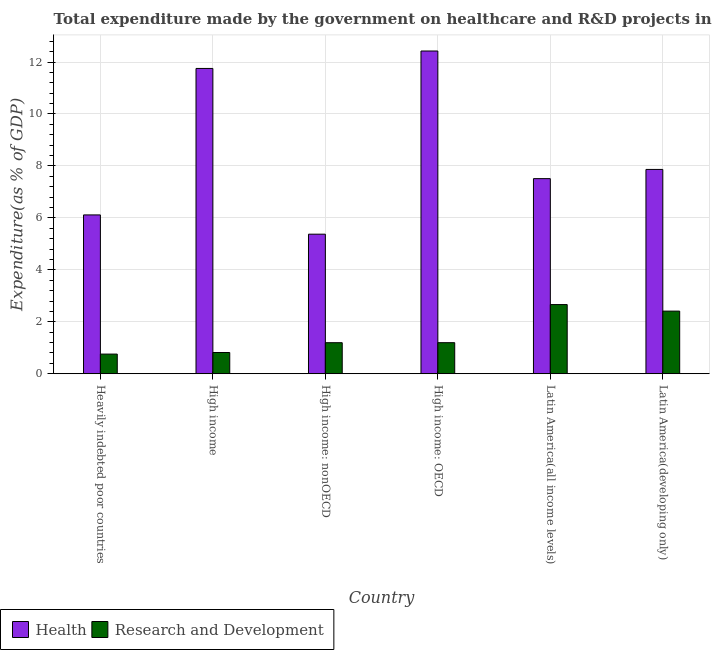How many groups of bars are there?
Offer a terse response. 6. Are the number of bars on each tick of the X-axis equal?
Your response must be concise. Yes. What is the label of the 6th group of bars from the left?
Your response must be concise. Latin America(developing only). What is the expenditure in healthcare in High income?
Your answer should be compact. 11.75. Across all countries, what is the maximum expenditure in healthcare?
Provide a succinct answer. 12.42. Across all countries, what is the minimum expenditure in healthcare?
Offer a very short reply. 5.37. In which country was the expenditure in r&d maximum?
Provide a succinct answer. Latin America(all income levels). In which country was the expenditure in healthcare minimum?
Your answer should be very brief. High income: nonOECD. What is the total expenditure in r&d in the graph?
Offer a very short reply. 9.04. What is the difference between the expenditure in healthcare in High income: OECD and that in Latin America(all income levels)?
Provide a short and direct response. 4.91. What is the difference between the expenditure in healthcare in High income: OECD and the expenditure in r&d in Latin America(developing only)?
Your answer should be compact. 10.01. What is the average expenditure in r&d per country?
Offer a very short reply. 1.51. What is the difference between the expenditure in r&d and expenditure in healthcare in High income: nonOECD?
Keep it short and to the point. -4.18. In how many countries, is the expenditure in r&d greater than 3.2 %?
Make the answer very short. 0. What is the ratio of the expenditure in healthcare in High income to that in Latin America(developing only)?
Provide a short and direct response. 1.49. Is the difference between the expenditure in healthcare in High income: OECD and Latin America(all income levels) greater than the difference between the expenditure in r&d in High income: OECD and Latin America(all income levels)?
Your answer should be very brief. Yes. What is the difference between the highest and the second highest expenditure in r&d?
Make the answer very short. 0.25. What is the difference between the highest and the lowest expenditure in healthcare?
Provide a succinct answer. 7.05. In how many countries, is the expenditure in r&d greater than the average expenditure in r&d taken over all countries?
Your answer should be very brief. 2. Is the sum of the expenditure in healthcare in Heavily indebted poor countries and High income: OECD greater than the maximum expenditure in r&d across all countries?
Your response must be concise. Yes. What does the 1st bar from the left in Latin America(developing only) represents?
Your answer should be very brief. Health. What does the 1st bar from the right in High income: OECD represents?
Provide a succinct answer. Research and Development. How many bars are there?
Your response must be concise. 12. Are all the bars in the graph horizontal?
Your answer should be compact. No. What is the difference between two consecutive major ticks on the Y-axis?
Provide a short and direct response. 2. Are the values on the major ticks of Y-axis written in scientific E-notation?
Offer a very short reply. No. Where does the legend appear in the graph?
Your response must be concise. Bottom left. What is the title of the graph?
Your response must be concise. Total expenditure made by the government on healthcare and R&D projects in 2011. What is the label or title of the Y-axis?
Your answer should be compact. Expenditure(as % of GDP). What is the Expenditure(as % of GDP) in Health in Heavily indebted poor countries?
Provide a short and direct response. 6.11. What is the Expenditure(as % of GDP) of Research and Development in Heavily indebted poor countries?
Offer a very short reply. 0.76. What is the Expenditure(as % of GDP) in Health in High income?
Ensure brevity in your answer.  11.75. What is the Expenditure(as % of GDP) in Research and Development in High income?
Offer a terse response. 0.82. What is the Expenditure(as % of GDP) in Health in High income: nonOECD?
Provide a short and direct response. 5.37. What is the Expenditure(as % of GDP) of Research and Development in High income: nonOECD?
Provide a succinct answer. 1.2. What is the Expenditure(as % of GDP) in Health in High income: OECD?
Your answer should be very brief. 12.42. What is the Expenditure(as % of GDP) in Research and Development in High income: OECD?
Your answer should be very brief. 1.2. What is the Expenditure(as % of GDP) of Health in Latin America(all income levels)?
Provide a succinct answer. 7.51. What is the Expenditure(as % of GDP) of Research and Development in Latin America(all income levels)?
Offer a very short reply. 2.66. What is the Expenditure(as % of GDP) in Health in Latin America(developing only)?
Your answer should be compact. 7.87. What is the Expenditure(as % of GDP) of Research and Development in Latin America(developing only)?
Ensure brevity in your answer.  2.41. Across all countries, what is the maximum Expenditure(as % of GDP) in Health?
Your response must be concise. 12.42. Across all countries, what is the maximum Expenditure(as % of GDP) of Research and Development?
Make the answer very short. 2.66. Across all countries, what is the minimum Expenditure(as % of GDP) in Health?
Offer a terse response. 5.37. Across all countries, what is the minimum Expenditure(as % of GDP) in Research and Development?
Offer a terse response. 0.76. What is the total Expenditure(as % of GDP) in Health in the graph?
Make the answer very short. 51.04. What is the total Expenditure(as % of GDP) in Research and Development in the graph?
Your answer should be very brief. 9.04. What is the difference between the Expenditure(as % of GDP) of Health in Heavily indebted poor countries and that in High income?
Provide a short and direct response. -5.64. What is the difference between the Expenditure(as % of GDP) of Research and Development in Heavily indebted poor countries and that in High income?
Provide a succinct answer. -0.06. What is the difference between the Expenditure(as % of GDP) of Health in Heavily indebted poor countries and that in High income: nonOECD?
Your answer should be compact. 0.74. What is the difference between the Expenditure(as % of GDP) of Research and Development in Heavily indebted poor countries and that in High income: nonOECD?
Make the answer very short. -0.44. What is the difference between the Expenditure(as % of GDP) in Health in Heavily indebted poor countries and that in High income: OECD?
Give a very brief answer. -6.31. What is the difference between the Expenditure(as % of GDP) in Research and Development in Heavily indebted poor countries and that in High income: OECD?
Provide a succinct answer. -0.44. What is the difference between the Expenditure(as % of GDP) of Health in Heavily indebted poor countries and that in Latin America(all income levels)?
Your answer should be compact. -1.4. What is the difference between the Expenditure(as % of GDP) in Research and Development in Heavily indebted poor countries and that in Latin America(all income levels)?
Offer a terse response. -1.91. What is the difference between the Expenditure(as % of GDP) in Health in Heavily indebted poor countries and that in Latin America(developing only)?
Make the answer very short. -1.75. What is the difference between the Expenditure(as % of GDP) of Research and Development in Heavily indebted poor countries and that in Latin America(developing only)?
Give a very brief answer. -1.65. What is the difference between the Expenditure(as % of GDP) in Health in High income and that in High income: nonOECD?
Give a very brief answer. 6.38. What is the difference between the Expenditure(as % of GDP) of Research and Development in High income and that in High income: nonOECD?
Offer a terse response. -0.38. What is the difference between the Expenditure(as % of GDP) in Health in High income and that in High income: OECD?
Offer a terse response. -0.67. What is the difference between the Expenditure(as % of GDP) of Research and Development in High income and that in High income: OECD?
Offer a very short reply. -0.38. What is the difference between the Expenditure(as % of GDP) in Health in High income and that in Latin America(all income levels)?
Offer a terse response. 4.24. What is the difference between the Expenditure(as % of GDP) of Research and Development in High income and that in Latin America(all income levels)?
Ensure brevity in your answer.  -1.85. What is the difference between the Expenditure(as % of GDP) of Health in High income and that in Latin America(developing only)?
Your answer should be very brief. 3.89. What is the difference between the Expenditure(as % of GDP) of Research and Development in High income and that in Latin America(developing only)?
Keep it short and to the point. -1.59. What is the difference between the Expenditure(as % of GDP) in Health in High income: nonOECD and that in High income: OECD?
Give a very brief answer. -7.05. What is the difference between the Expenditure(as % of GDP) in Research and Development in High income: nonOECD and that in High income: OECD?
Provide a succinct answer. -0. What is the difference between the Expenditure(as % of GDP) of Health in High income: nonOECD and that in Latin America(all income levels)?
Provide a short and direct response. -2.14. What is the difference between the Expenditure(as % of GDP) of Research and Development in High income: nonOECD and that in Latin America(all income levels)?
Provide a short and direct response. -1.47. What is the difference between the Expenditure(as % of GDP) of Health in High income: nonOECD and that in Latin America(developing only)?
Make the answer very short. -2.49. What is the difference between the Expenditure(as % of GDP) in Research and Development in High income: nonOECD and that in Latin America(developing only)?
Give a very brief answer. -1.22. What is the difference between the Expenditure(as % of GDP) in Health in High income: OECD and that in Latin America(all income levels)?
Ensure brevity in your answer.  4.91. What is the difference between the Expenditure(as % of GDP) in Research and Development in High income: OECD and that in Latin America(all income levels)?
Provide a short and direct response. -1.47. What is the difference between the Expenditure(as % of GDP) of Health in High income: OECD and that in Latin America(developing only)?
Offer a terse response. 4.56. What is the difference between the Expenditure(as % of GDP) in Research and Development in High income: OECD and that in Latin America(developing only)?
Provide a short and direct response. -1.21. What is the difference between the Expenditure(as % of GDP) in Health in Latin America(all income levels) and that in Latin America(developing only)?
Offer a very short reply. -0.35. What is the difference between the Expenditure(as % of GDP) of Research and Development in Latin America(all income levels) and that in Latin America(developing only)?
Your response must be concise. 0.25. What is the difference between the Expenditure(as % of GDP) of Health in Heavily indebted poor countries and the Expenditure(as % of GDP) of Research and Development in High income?
Your answer should be compact. 5.3. What is the difference between the Expenditure(as % of GDP) of Health in Heavily indebted poor countries and the Expenditure(as % of GDP) of Research and Development in High income: nonOECD?
Provide a short and direct response. 4.92. What is the difference between the Expenditure(as % of GDP) of Health in Heavily indebted poor countries and the Expenditure(as % of GDP) of Research and Development in High income: OECD?
Give a very brief answer. 4.92. What is the difference between the Expenditure(as % of GDP) in Health in Heavily indebted poor countries and the Expenditure(as % of GDP) in Research and Development in Latin America(all income levels)?
Make the answer very short. 3.45. What is the difference between the Expenditure(as % of GDP) of Health in Heavily indebted poor countries and the Expenditure(as % of GDP) of Research and Development in Latin America(developing only)?
Offer a very short reply. 3.7. What is the difference between the Expenditure(as % of GDP) of Health in High income and the Expenditure(as % of GDP) of Research and Development in High income: nonOECD?
Your response must be concise. 10.56. What is the difference between the Expenditure(as % of GDP) in Health in High income and the Expenditure(as % of GDP) in Research and Development in High income: OECD?
Keep it short and to the point. 10.56. What is the difference between the Expenditure(as % of GDP) in Health in High income and the Expenditure(as % of GDP) in Research and Development in Latin America(all income levels)?
Your answer should be compact. 9.09. What is the difference between the Expenditure(as % of GDP) in Health in High income and the Expenditure(as % of GDP) in Research and Development in Latin America(developing only)?
Offer a terse response. 9.34. What is the difference between the Expenditure(as % of GDP) in Health in High income: nonOECD and the Expenditure(as % of GDP) in Research and Development in High income: OECD?
Your response must be concise. 4.18. What is the difference between the Expenditure(as % of GDP) in Health in High income: nonOECD and the Expenditure(as % of GDP) in Research and Development in Latin America(all income levels)?
Give a very brief answer. 2.71. What is the difference between the Expenditure(as % of GDP) of Health in High income: nonOECD and the Expenditure(as % of GDP) of Research and Development in Latin America(developing only)?
Keep it short and to the point. 2.96. What is the difference between the Expenditure(as % of GDP) in Health in High income: OECD and the Expenditure(as % of GDP) in Research and Development in Latin America(all income levels)?
Offer a very short reply. 9.76. What is the difference between the Expenditure(as % of GDP) in Health in High income: OECD and the Expenditure(as % of GDP) in Research and Development in Latin America(developing only)?
Provide a short and direct response. 10.01. What is the difference between the Expenditure(as % of GDP) in Health in Latin America(all income levels) and the Expenditure(as % of GDP) in Research and Development in Latin America(developing only)?
Offer a terse response. 5.1. What is the average Expenditure(as % of GDP) of Health per country?
Provide a short and direct response. 8.51. What is the average Expenditure(as % of GDP) in Research and Development per country?
Provide a short and direct response. 1.51. What is the difference between the Expenditure(as % of GDP) of Health and Expenditure(as % of GDP) of Research and Development in Heavily indebted poor countries?
Ensure brevity in your answer.  5.36. What is the difference between the Expenditure(as % of GDP) of Health and Expenditure(as % of GDP) of Research and Development in High income?
Keep it short and to the point. 10.94. What is the difference between the Expenditure(as % of GDP) in Health and Expenditure(as % of GDP) in Research and Development in High income: nonOECD?
Your response must be concise. 4.18. What is the difference between the Expenditure(as % of GDP) of Health and Expenditure(as % of GDP) of Research and Development in High income: OECD?
Your answer should be very brief. 11.23. What is the difference between the Expenditure(as % of GDP) in Health and Expenditure(as % of GDP) in Research and Development in Latin America(all income levels)?
Make the answer very short. 4.85. What is the difference between the Expenditure(as % of GDP) in Health and Expenditure(as % of GDP) in Research and Development in Latin America(developing only)?
Your response must be concise. 5.45. What is the ratio of the Expenditure(as % of GDP) in Health in Heavily indebted poor countries to that in High income?
Provide a short and direct response. 0.52. What is the ratio of the Expenditure(as % of GDP) of Research and Development in Heavily indebted poor countries to that in High income?
Give a very brief answer. 0.93. What is the ratio of the Expenditure(as % of GDP) of Health in Heavily indebted poor countries to that in High income: nonOECD?
Offer a terse response. 1.14. What is the ratio of the Expenditure(as % of GDP) in Research and Development in Heavily indebted poor countries to that in High income: nonOECD?
Your answer should be compact. 0.63. What is the ratio of the Expenditure(as % of GDP) of Health in Heavily indebted poor countries to that in High income: OECD?
Ensure brevity in your answer.  0.49. What is the ratio of the Expenditure(as % of GDP) of Research and Development in Heavily indebted poor countries to that in High income: OECD?
Your response must be concise. 0.63. What is the ratio of the Expenditure(as % of GDP) in Health in Heavily indebted poor countries to that in Latin America(all income levels)?
Your answer should be very brief. 0.81. What is the ratio of the Expenditure(as % of GDP) of Research and Development in Heavily indebted poor countries to that in Latin America(all income levels)?
Provide a short and direct response. 0.28. What is the ratio of the Expenditure(as % of GDP) in Health in Heavily indebted poor countries to that in Latin America(developing only)?
Your answer should be compact. 0.78. What is the ratio of the Expenditure(as % of GDP) of Research and Development in Heavily indebted poor countries to that in Latin America(developing only)?
Provide a short and direct response. 0.31. What is the ratio of the Expenditure(as % of GDP) of Health in High income to that in High income: nonOECD?
Your answer should be very brief. 2.19. What is the ratio of the Expenditure(as % of GDP) of Research and Development in High income to that in High income: nonOECD?
Your answer should be very brief. 0.68. What is the ratio of the Expenditure(as % of GDP) in Health in High income to that in High income: OECD?
Your answer should be very brief. 0.95. What is the ratio of the Expenditure(as % of GDP) of Research and Development in High income to that in High income: OECD?
Keep it short and to the point. 0.68. What is the ratio of the Expenditure(as % of GDP) of Health in High income to that in Latin America(all income levels)?
Your answer should be very brief. 1.56. What is the ratio of the Expenditure(as % of GDP) of Research and Development in High income to that in Latin America(all income levels)?
Offer a terse response. 0.31. What is the ratio of the Expenditure(as % of GDP) in Health in High income to that in Latin America(developing only)?
Provide a short and direct response. 1.49. What is the ratio of the Expenditure(as % of GDP) of Research and Development in High income to that in Latin America(developing only)?
Make the answer very short. 0.34. What is the ratio of the Expenditure(as % of GDP) in Health in High income: nonOECD to that in High income: OECD?
Make the answer very short. 0.43. What is the ratio of the Expenditure(as % of GDP) in Health in High income: nonOECD to that in Latin America(all income levels)?
Make the answer very short. 0.72. What is the ratio of the Expenditure(as % of GDP) in Research and Development in High income: nonOECD to that in Latin America(all income levels)?
Provide a succinct answer. 0.45. What is the ratio of the Expenditure(as % of GDP) of Health in High income: nonOECD to that in Latin America(developing only)?
Ensure brevity in your answer.  0.68. What is the ratio of the Expenditure(as % of GDP) of Research and Development in High income: nonOECD to that in Latin America(developing only)?
Ensure brevity in your answer.  0.5. What is the ratio of the Expenditure(as % of GDP) in Health in High income: OECD to that in Latin America(all income levels)?
Keep it short and to the point. 1.65. What is the ratio of the Expenditure(as % of GDP) in Research and Development in High income: OECD to that in Latin America(all income levels)?
Your response must be concise. 0.45. What is the ratio of the Expenditure(as % of GDP) of Health in High income: OECD to that in Latin America(developing only)?
Make the answer very short. 1.58. What is the ratio of the Expenditure(as % of GDP) of Research and Development in High income: OECD to that in Latin America(developing only)?
Offer a terse response. 0.5. What is the ratio of the Expenditure(as % of GDP) of Health in Latin America(all income levels) to that in Latin America(developing only)?
Offer a terse response. 0.95. What is the ratio of the Expenditure(as % of GDP) of Research and Development in Latin America(all income levels) to that in Latin America(developing only)?
Make the answer very short. 1.1. What is the difference between the highest and the second highest Expenditure(as % of GDP) in Health?
Your response must be concise. 0.67. What is the difference between the highest and the second highest Expenditure(as % of GDP) in Research and Development?
Your answer should be very brief. 0.25. What is the difference between the highest and the lowest Expenditure(as % of GDP) in Health?
Provide a succinct answer. 7.05. What is the difference between the highest and the lowest Expenditure(as % of GDP) of Research and Development?
Offer a terse response. 1.91. 